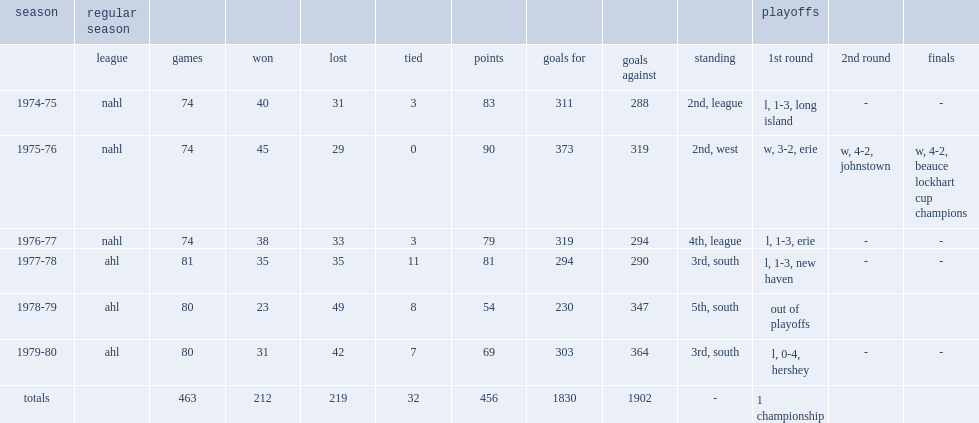How many goals did syracuse score in the 1979-80 season? 364.0. 